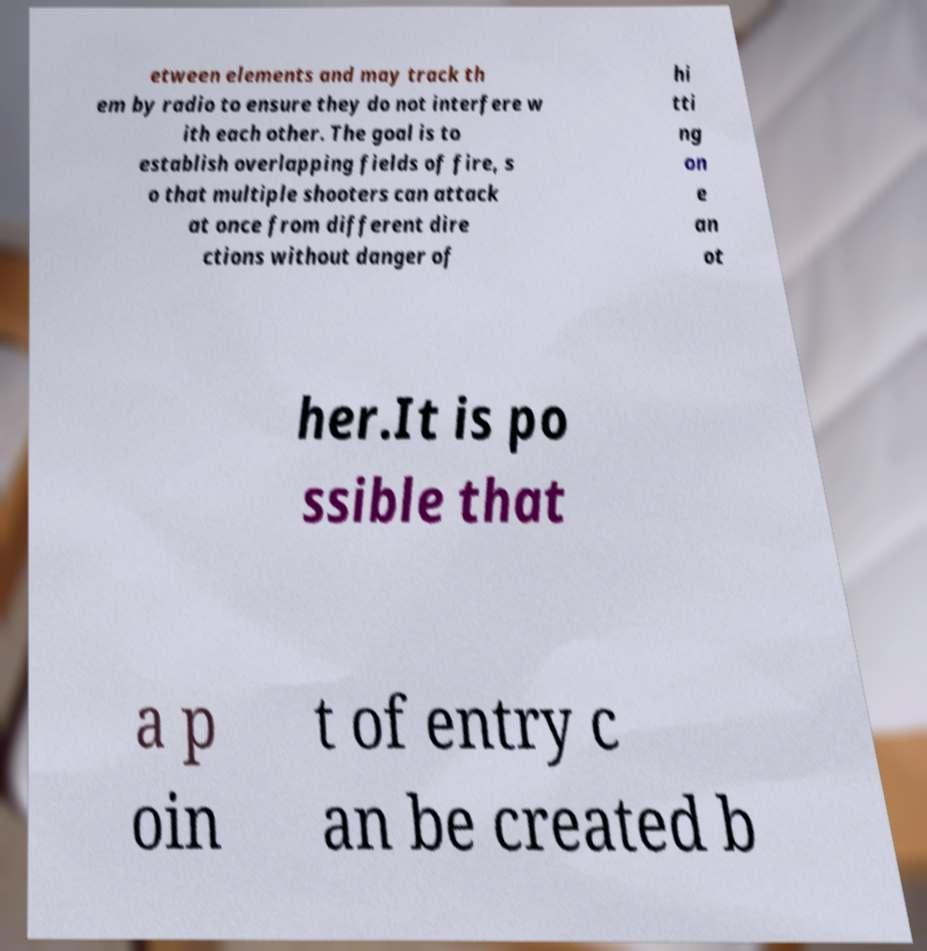Could you assist in decoding the text presented in this image and type it out clearly? etween elements and may track th em by radio to ensure they do not interfere w ith each other. The goal is to establish overlapping fields of fire, s o that multiple shooters can attack at once from different dire ctions without danger of hi tti ng on e an ot her.It is po ssible that a p oin t of entry c an be created b 